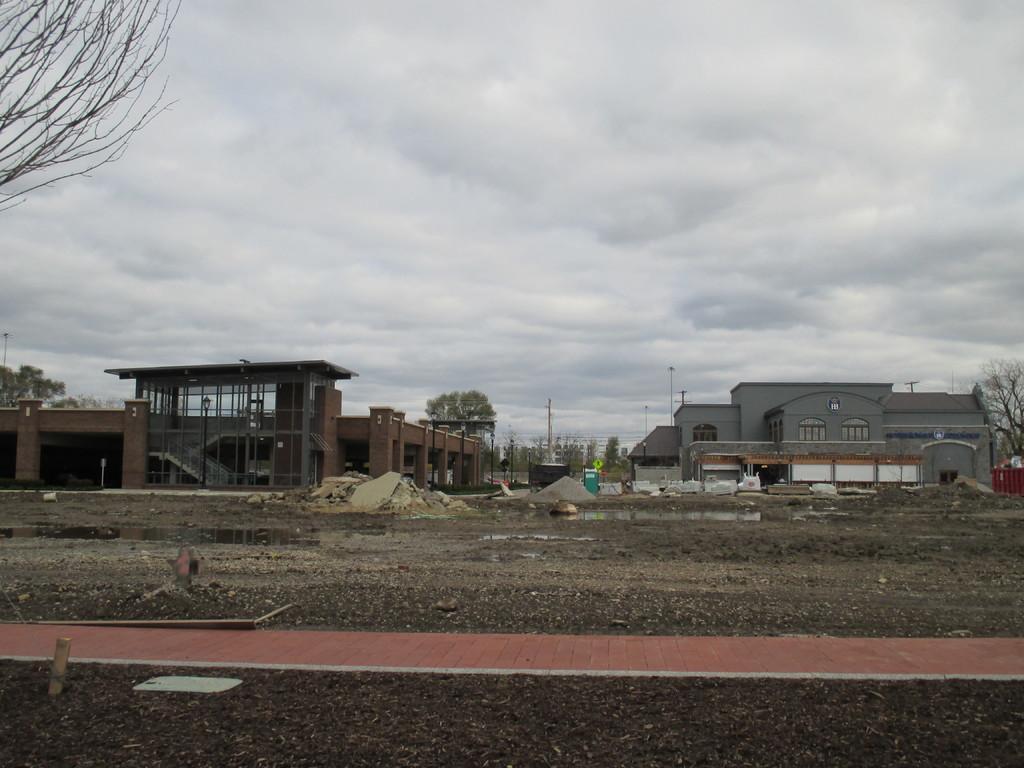Describe this image in one or two sentences. In this image we can see sand, muddy water, path, buildings, wires, poles, trees, light poles and the cloudy sky in the background. 